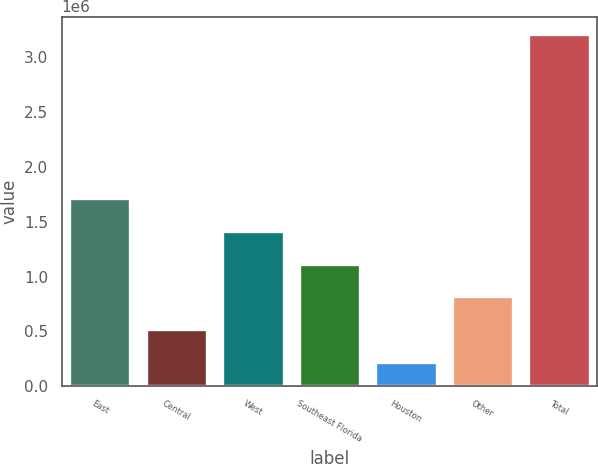<chart> <loc_0><loc_0><loc_500><loc_500><bar_chart><fcel>East<fcel>Central<fcel>West<fcel>Southeast Florida<fcel>Houston<fcel>Other<fcel>Total<nl><fcel>1.71747e+06<fcel>521606<fcel>1.4185e+06<fcel>1.11954e+06<fcel>222641<fcel>820571<fcel>3.21229e+06<nl></chart> 